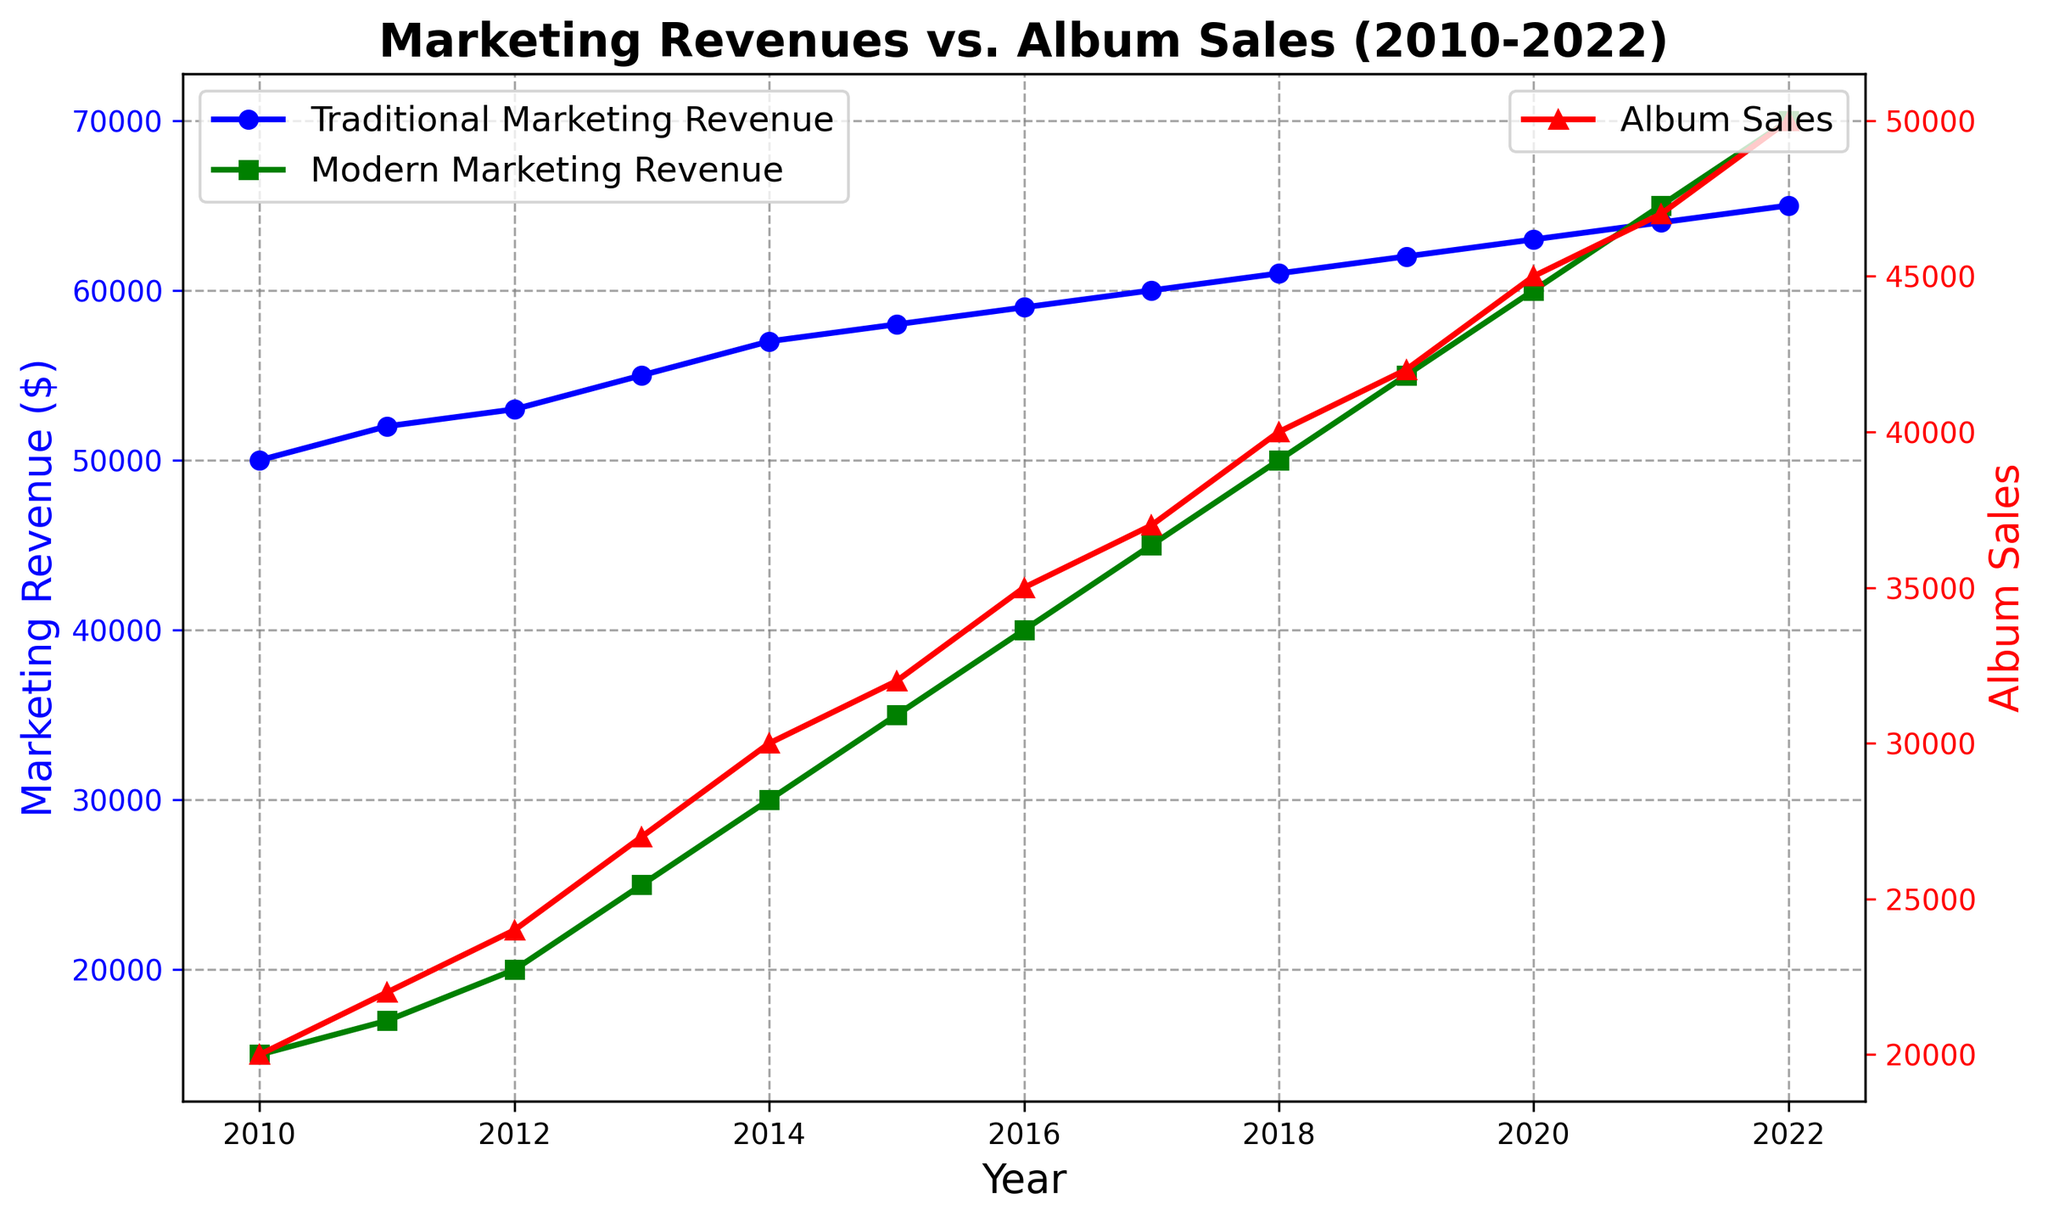What trend do you observe in traditional marketing revenue from 2010 to 2022? Traditional marketing revenue shows a consistent, gradual increase from $50,000 in 2010 to $65,000 in 2022 by about $1,000 per year.
Answer: Gradual increase How does album sales in 2022 compare to the album sales in 2015? In 2015, album sales were 32,000, and by 2022, they increased to 50,000. The increase is 50,000 - 32,000 = 18,000.
Answer: Increased by 18,000 Which year shows the highest revenue from modern marketing channels? The highest revenue from modern marketing channels is in 2022, with $70,000.
Answer: 2022 What is the difference between traditional marketing revenue and modern marketing revenue in 2020? In 2020, traditional marketing revenue is $63,000, and modern marketing revenue is $60,000. The difference is 63,000 - 60,000 = $3,000.
Answer: $3,000 Between which consecutive years did album sales see the highest increase? The highest increase in album sales occurred between 2019 and 2020. In 2019, sales were 42,000 and in 2020, sales were 45,000. The increase is 45,000 - 42,000 = 3,000.
Answer: 2019-2020 What trend do you see in modern marketing revenue from 2010 to 2022? Modern marketing revenue shows a consistent, significant increase from $15,000 in 2010 to $70,000 in 2022, with an annual increase rate.
Answer: Consistent significant increase In which year do traditional and modern marketing revenues become equal? Traditional and modern marketing revenues become equal in 2021, both reaching $65,000.
Answer: 2021 What is the combined total of traditional and modern marketing revenues in 2015? In 2015, traditional marketing revenue is $58,000 and modern marketing revenue is $35,000. The combined total is 58,000 + 35,000 = $93,000.
Answer: $93,000 Describe the visual change in the plot line of traditional marketing revenue from 2010 to 2022. The plot line for traditional marketing revenue is blue and shows a steady incline with no sharp changes, marked by circles ('o').
Answer: Blue, steady incline How did album sales trend from 2010 to 2022, and how does it relate to modern marketing revenue over the same period? Album sales increased from 20,000 in 2010 to 50,000 in 2022, showing a consistent upward trend. Modern marketing revenue also increased significantly during the same time, from $15,000 to $70,000, suggesting a possible correlation between rising modern marketing revenue and increasing album sales.
Answer: Consistent increase in both 